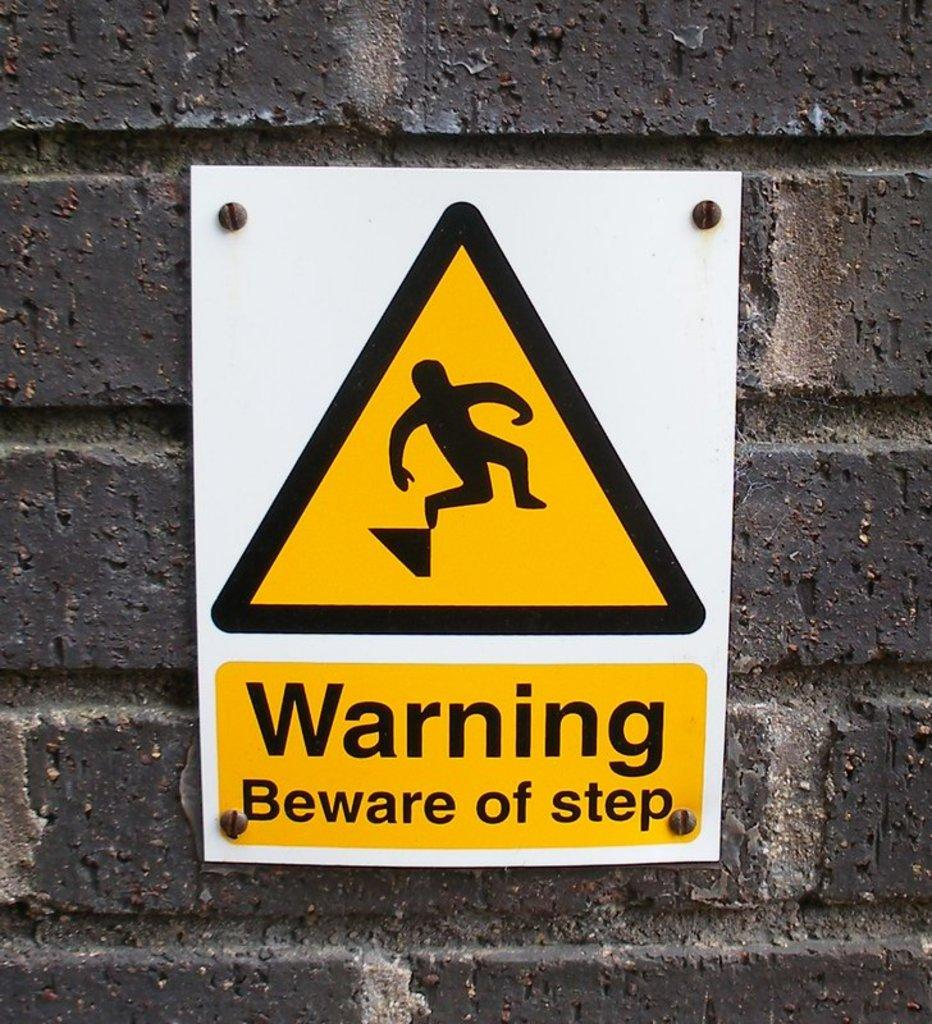<image>
Summarize the visual content of the image. A sign warning people of a step posted to a brick wall. 